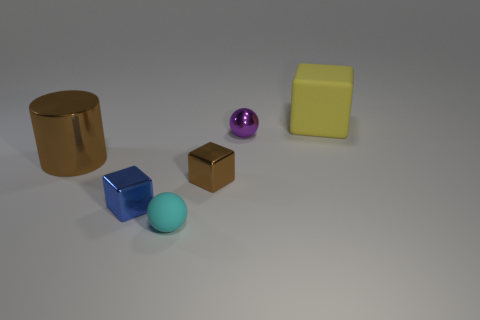What number of tiny spheres are right of the tiny metallic cube behind the small block left of the tiny brown cube?
Your answer should be compact. 1. What number of purple metallic things are on the right side of the large yellow cube?
Your answer should be compact. 0. There is a rubber thing that is the same shape as the tiny purple metal object; what color is it?
Your response must be concise. Cyan. What material is the cube that is to the right of the cyan ball and to the left of the large yellow matte thing?
Provide a succinct answer. Metal. Is the size of the blue thing to the left of the brown metallic block the same as the large metal cylinder?
Make the answer very short. No. What material is the big brown cylinder?
Ensure brevity in your answer.  Metal. There is a cube that is behind the small purple ball; what is its color?
Your answer should be very brief. Yellow. How many large objects are red rubber blocks or purple metal objects?
Your response must be concise. 0. Do the metal object that is left of the tiny blue metal thing and the rubber object left of the big rubber thing have the same color?
Offer a very short reply. No. What number of other objects are the same color as the tiny shiny ball?
Make the answer very short. 0. 